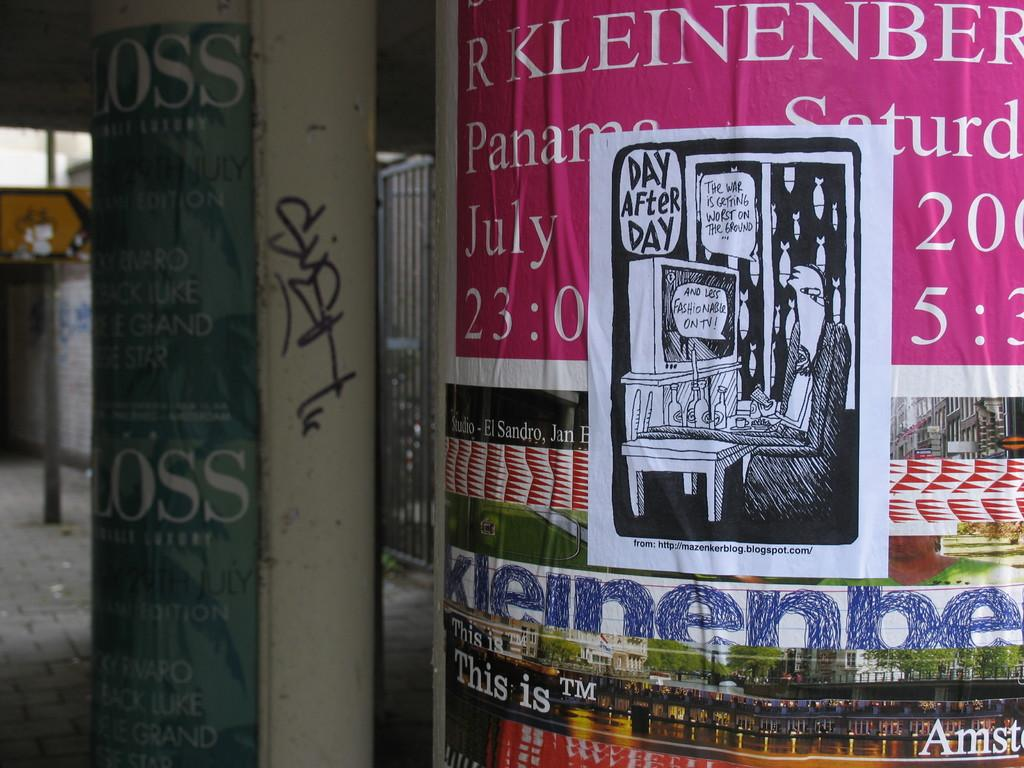<image>
Relay a brief, clear account of the picture shown. column covered in posters and a cartoon drawing of day after day 